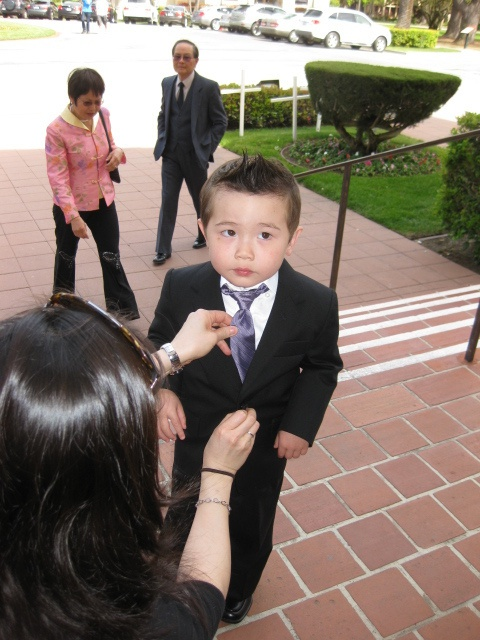Describe the objects in this image and their specific colors. I can see people in brown, black, tan, and gray tones, people in brown, black, gray, and darkgray tones, people in brown, black, lightpink, and white tones, people in brown, black, gray, and tan tones, and car in brown, white, darkgray, gray, and lightgray tones in this image. 